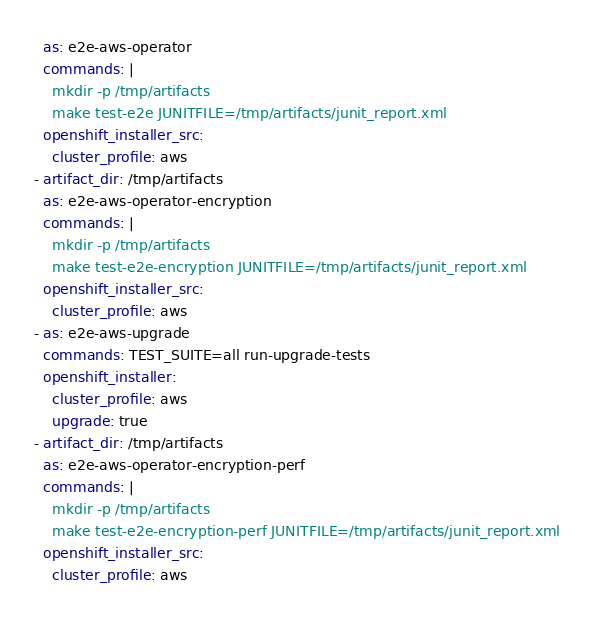<code> <loc_0><loc_0><loc_500><loc_500><_YAML_>  as: e2e-aws-operator
  commands: |
    mkdir -p /tmp/artifacts
    make test-e2e JUNITFILE=/tmp/artifacts/junit_report.xml
  openshift_installer_src:
    cluster_profile: aws
- artifact_dir: /tmp/artifacts
  as: e2e-aws-operator-encryption
  commands: |
    mkdir -p /tmp/artifacts
    make test-e2e-encryption JUNITFILE=/tmp/artifacts/junit_report.xml
  openshift_installer_src:
    cluster_profile: aws
- as: e2e-aws-upgrade
  commands: TEST_SUITE=all run-upgrade-tests
  openshift_installer:
    cluster_profile: aws
    upgrade: true
- artifact_dir: /tmp/artifacts
  as: e2e-aws-operator-encryption-perf
  commands: |
    mkdir -p /tmp/artifacts
    make test-e2e-encryption-perf JUNITFILE=/tmp/artifacts/junit_report.xml
  openshift_installer_src:
    cluster_profile: aws
</code> 